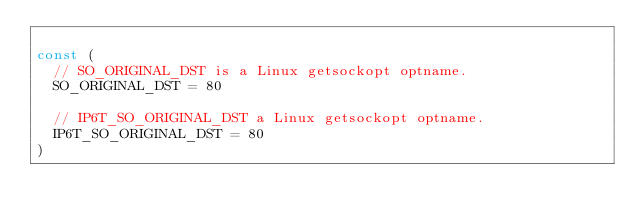<code> <loc_0><loc_0><loc_500><loc_500><_Go_>
const (
	// SO_ORIGINAL_DST is a Linux getsockopt optname.
	SO_ORIGINAL_DST = 80

	// IP6T_SO_ORIGINAL_DST a Linux getsockopt optname.
	IP6T_SO_ORIGINAL_DST = 80
)
</code> 